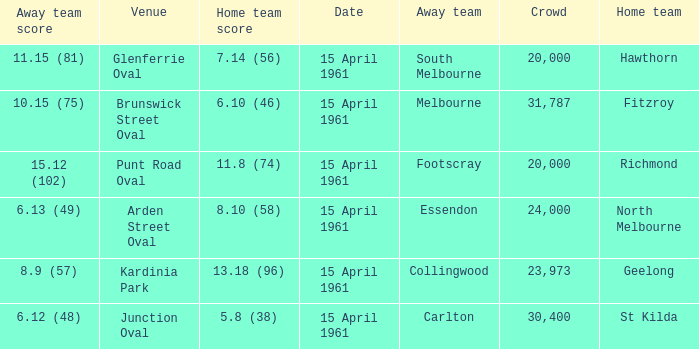What was the score for the home team St Kilda? 5.8 (38). Can you give me this table as a dict? {'header': ['Away team score', 'Venue', 'Home team score', 'Date', 'Away team', 'Crowd', 'Home team'], 'rows': [['11.15 (81)', 'Glenferrie Oval', '7.14 (56)', '15 April 1961', 'South Melbourne', '20,000', 'Hawthorn'], ['10.15 (75)', 'Brunswick Street Oval', '6.10 (46)', '15 April 1961', 'Melbourne', '31,787', 'Fitzroy'], ['15.12 (102)', 'Punt Road Oval', '11.8 (74)', '15 April 1961', 'Footscray', '20,000', 'Richmond'], ['6.13 (49)', 'Arden Street Oval', '8.10 (58)', '15 April 1961', 'Essendon', '24,000', 'North Melbourne'], ['8.9 (57)', 'Kardinia Park', '13.18 (96)', '15 April 1961', 'Collingwood', '23,973', 'Geelong'], ['6.12 (48)', 'Junction Oval', '5.8 (38)', '15 April 1961', 'Carlton', '30,400', 'St Kilda']]} 